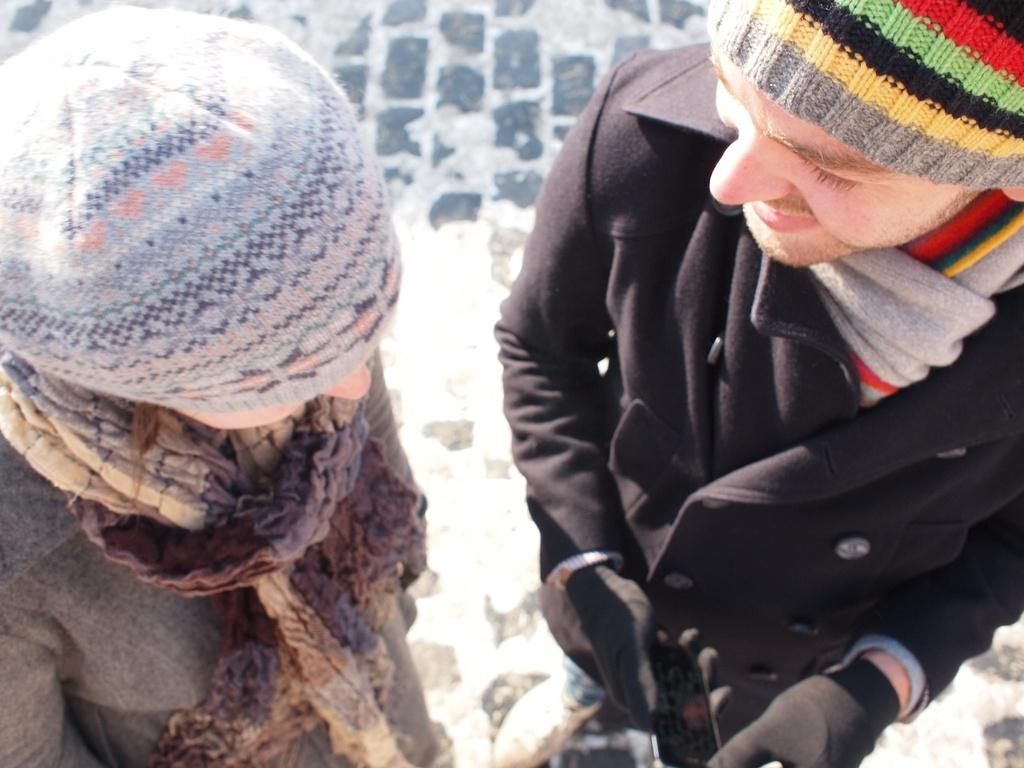How many people are in the image? There are two persons in the image. What are the persons doing in the image? The persons are standing. What are the persons wearing in the image? The persons are wearing clothes. Can you see a plane flying over the wax river in the image? There is no plane, wax, or river present in the image. 